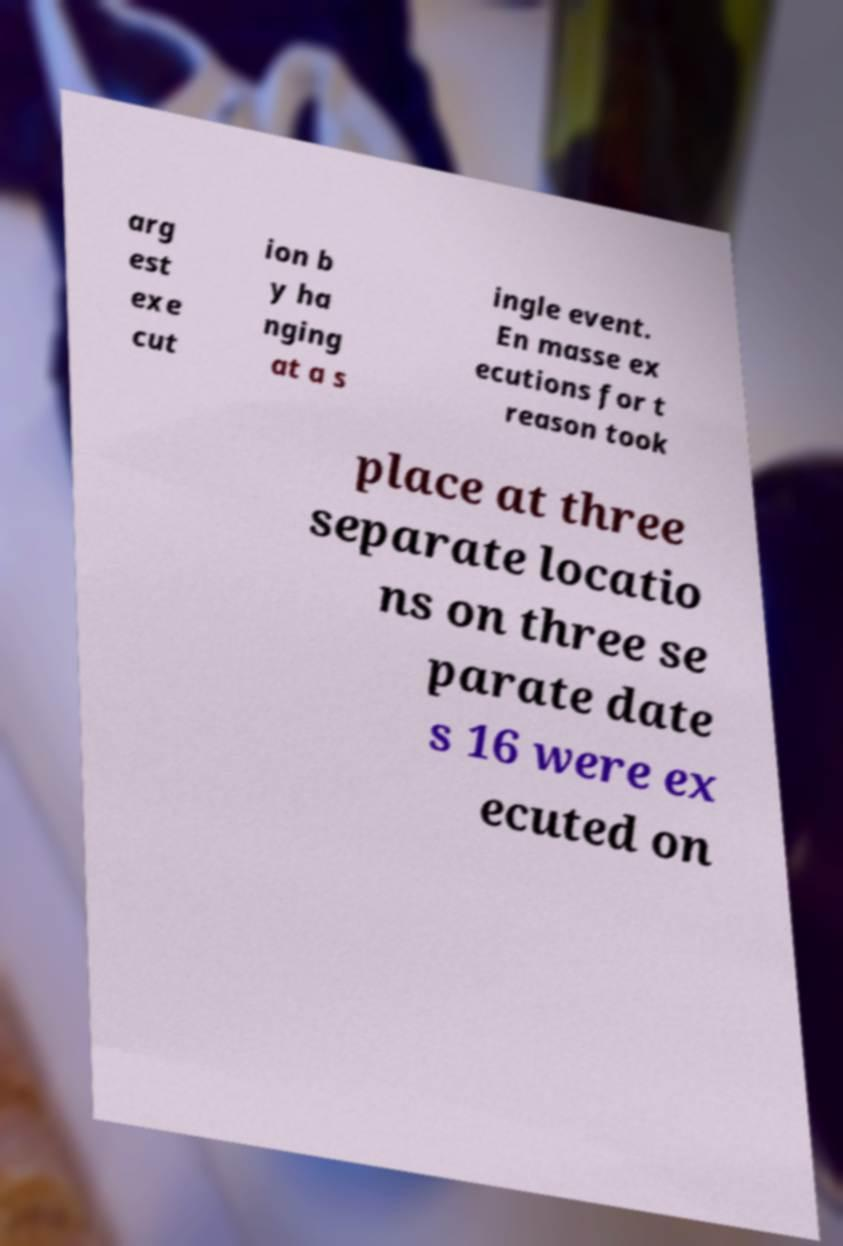Please identify and transcribe the text found in this image. arg est exe cut ion b y ha nging at a s ingle event. En masse ex ecutions for t reason took place at three separate locatio ns on three se parate date s 16 were ex ecuted on 